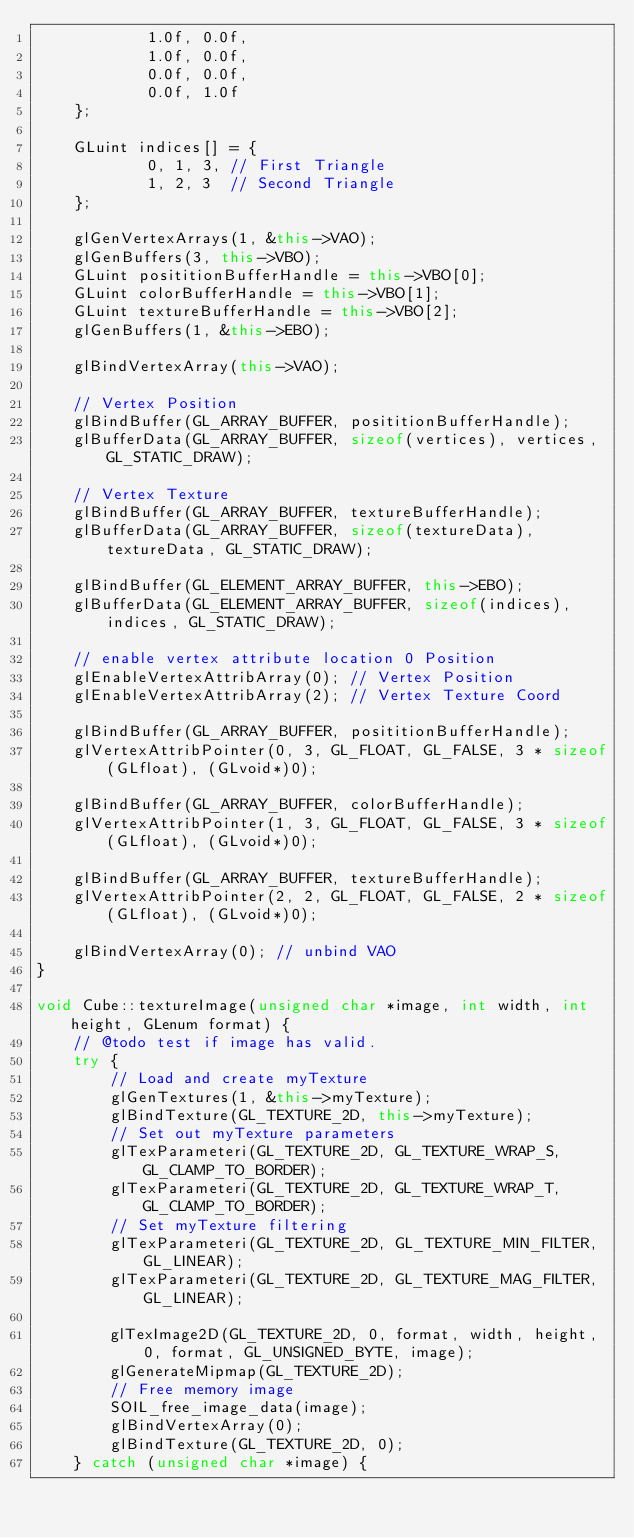Convert code to text. <code><loc_0><loc_0><loc_500><loc_500><_C++_>            1.0f, 0.0f,
            1.0f, 0.0f,
            0.0f, 0.0f,
            0.0f, 1.0f
    };

    GLuint indices[] = {
            0, 1, 3, // First Triangle
            1, 2, 3  // Second Triangle
    };

    glGenVertexArrays(1, &this->VAO);
    glGenBuffers(3, this->VBO);
    GLuint posititionBufferHandle = this->VBO[0];
    GLuint colorBufferHandle = this->VBO[1];
    GLuint textureBufferHandle = this->VBO[2];
    glGenBuffers(1, &this->EBO);

    glBindVertexArray(this->VAO);

    // Vertex Position
    glBindBuffer(GL_ARRAY_BUFFER, posititionBufferHandle);
    glBufferData(GL_ARRAY_BUFFER, sizeof(vertices), vertices, GL_STATIC_DRAW);

    // Vertex Texture
    glBindBuffer(GL_ARRAY_BUFFER, textureBufferHandle);
    glBufferData(GL_ARRAY_BUFFER, sizeof(textureData), textureData, GL_STATIC_DRAW);

    glBindBuffer(GL_ELEMENT_ARRAY_BUFFER, this->EBO);
    glBufferData(GL_ELEMENT_ARRAY_BUFFER, sizeof(indices), indices, GL_STATIC_DRAW);

    // enable vertex attribute location 0 Position
    glEnableVertexAttribArray(0); // Vertex Position
    glEnableVertexAttribArray(2); // Vertex Texture Coord

    glBindBuffer(GL_ARRAY_BUFFER, posititionBufferHandle);
    glVertexAttribPointer(0, 3, GL_FLOAT, GL_FALSE, 3 * sizeof(GLfloat), (GLvoid*)0);

    glBindBuffer(GL_ARRAY_BUFFER, colorBufferHandle);
    glVertexAttribPointer(1, 3, GL_FLOAT, GL_FALSE, 3 * sizeof(GLfloat), (GLvoid*)0);

    glBindBuffer(GL_ARRAY_BUFFER, textureBufferHandle);
    glVertexAttribPointer(2, 2, GL_FLOAT, GL_FALSE, 2 * sizeof(GLfloat), (GLvoid*)0);

    glBindVertexArray(0); // unbind VAO
}

void Cube::textureImage(unsigned char *image, int width, int height, GLenum format) {
    // @todo test if image has valid.
    try {
        // Load and create myTexture
        glGenTextures(1, &this->myTexture);
        glBindTexture(GL_TEXTURE_2D, this->myTexture);
        // Set out myTexture parameters
        glTexParameteri(GL_TEXTURE_2D, GL_TEXTURE_WRAP_S, GL_CLAMP_TO_BORDER);
        glTexParameteri(GL_TEXTURE_2D, GL_TEXTURE_WRAP_T, GL_CLAMP_TO_BORDER);
        // Set myTexture filtering
        glTexParameteri(GL_TEXTURE_2D, GL_TEXTURE_MIN_FILTER, GL_LINEAR);
        glTexParameteri(GL_TEXTURE_2D, GL_TEXTURE_MAG_FILTER, GL_LINEAR);

        glTexImage2D(GL_TEXTURE_2D, 0, format, width, height, 0, format, GL_UNSIGNED_BYTE, image);
        glGenerateMipmap(GL_TEXTURE_2D);
        // Free memory image
        SOIL_free_image_data(image);
        glBindVertexArray(0);
        glBindTexture(GL_TEXTURE_2D, 0);
    } catch (unsigned char *image) {</code> 